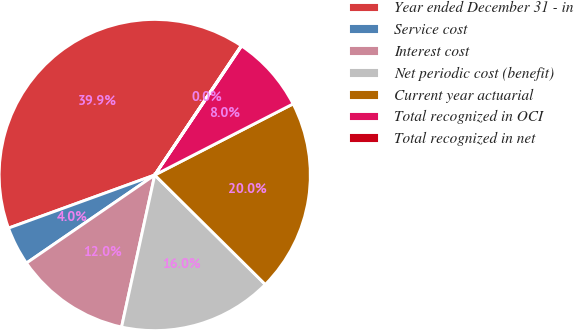<chart> <loc_0><loc_0><loc_500><loc_500><pie_chart><fcel>Year ended December 31 - in<fcel>Service cost<fcel>Interest cost<fcel>Net periodic cost (benefit)<fcel>Current year actuarial<fcel>Total recognized in OCI<fcel>Total recognized in net<nl><fcel>39.93%<fcel>4.03%<fcel>12.01%<fcel>16.0%<fcel>19.98%<fcel>8.02%<fcel>0.04%<nl></chart> 